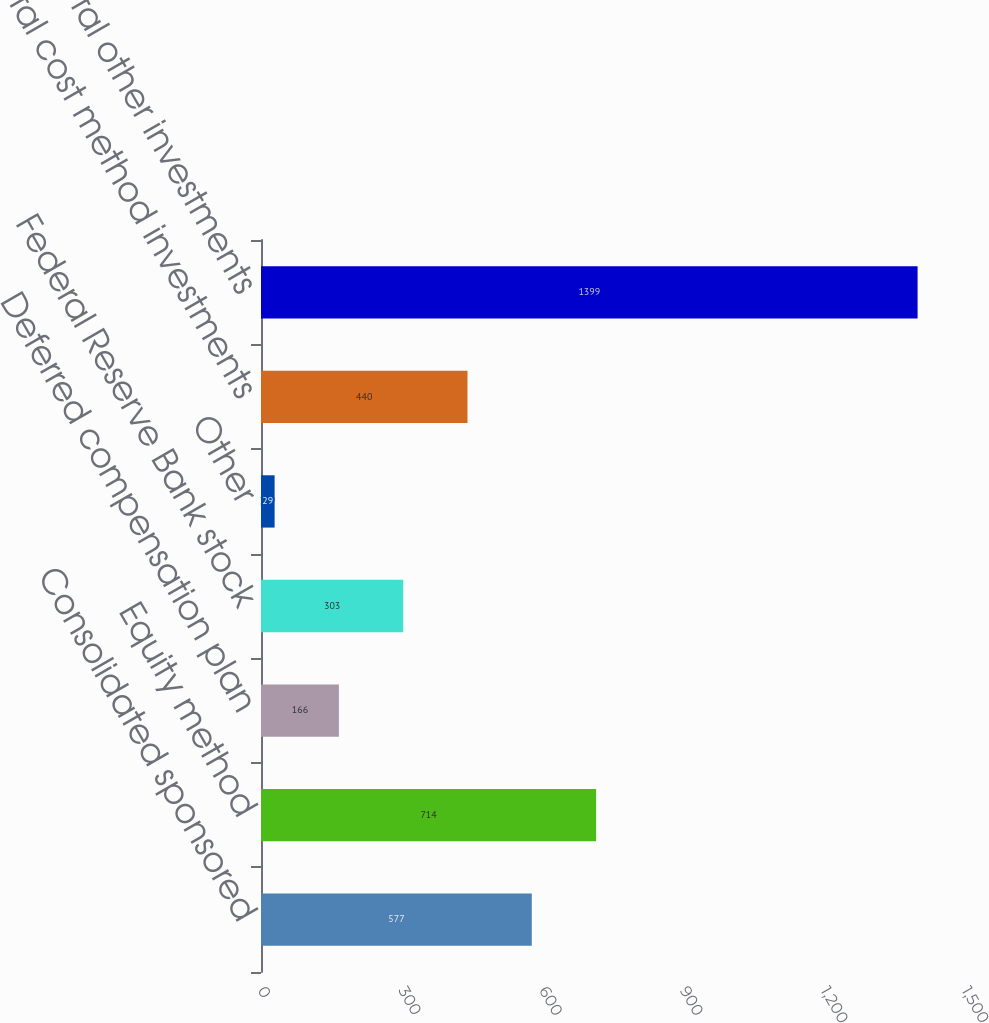Convert chart to OTSL. <chart><loc_0><loc_0><loc_500><loc_500><bar_chart><fcel>Consolidated sponsored<fcel>Equity method<fcel>Deferred compensation plan<fcel>Federal Reserve Bank stock<fcel>Other<fcel>Total cost method investments<fcel>Total other investments<nl><fcel>577<fcel>714<fcel>166<fcel>303<fcel>29<fcel>440<fcel>1399<nl></chart> 